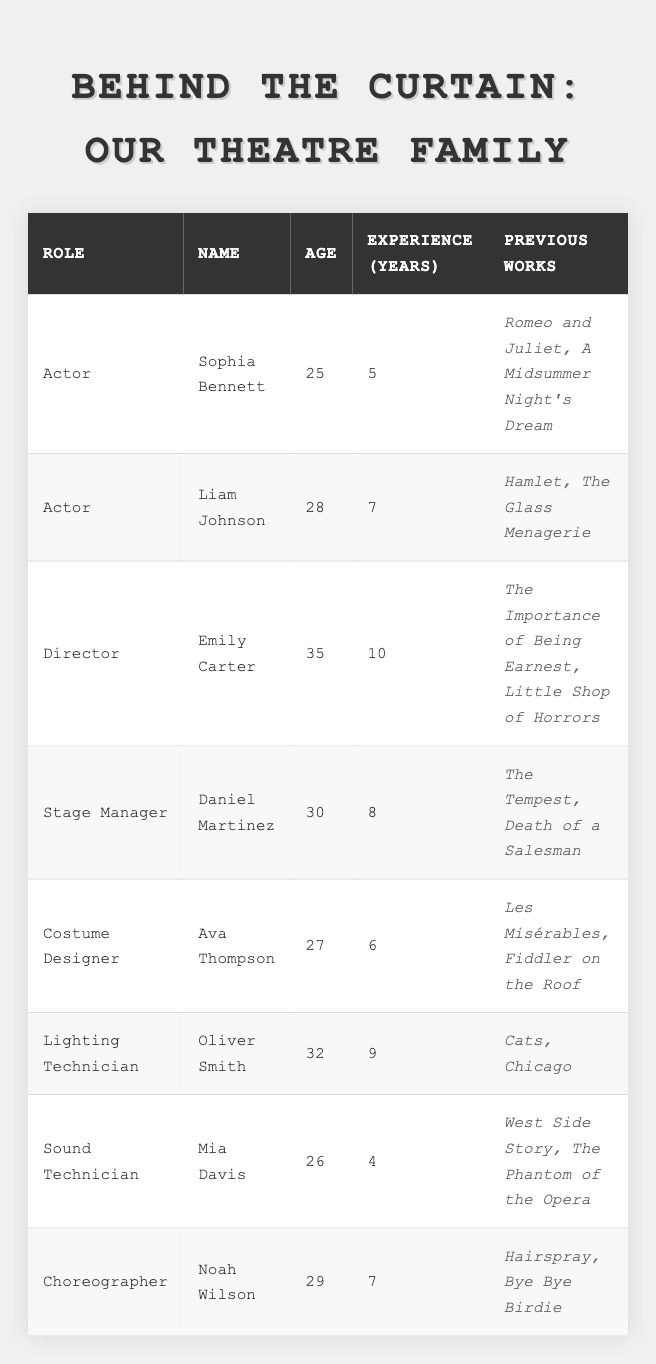What is the age of Sophia Bennett? Sophia Bennett is listed in the table, and her age is directly stated as 25.
Answer: 25 Who has the most experience? Emily Carter is a director with 10 years of experience, which is the highest compared to others in the table.
Answer: Emily Carter How many years of experience does Mia Davis have? Mia Davis is listed as a sound technician with 4 years of experience, which can be found in her entry.
Answer: 4 Are there any actors older than 30? The table shows that the only two actors are Sophia Bennett (25) and Liam Johnson (28), both of whom are younger than 30.
Answer: No What is the average age of the cast and crew? To find the average age, add all ages (25 + 28 + 35 + 30 + 27 + 32 + 26 + 29 = 232). Then divide by the number of entries (8), resulting in an average age of 29.
Answer: 29 How many total years of experience do the actors have? The two actors are Sophia Bennett (5 years) and Liam Johnson (7 years). Adding their experiences together gives 5 + 7 = 12 years.
Answer: 12 Which role has the youngest individual? Sophia Bennett is the youngest individual listed at 25 years old and she is an actor.
Answer: Actor Is Liam Johnson older than Daniel Martinez? Liam Johnson is 28 years old, while Daniel Martinez is 30 years old, making Daniel older than Liam.
Answer: No What role does Noah Wilson have and what is his experience? Noah Wilson is listed as a choreographer with 7 years of experience, found directly under his entry.
Answer: Choreographer, 7 years How many different roles are represented in the table? There are eight entries with distinct roles: Actor, Director, Stage Manager, Costume Designer, Lighting Technician, Sound Technician, and Choreographer. This makes a total of 7 different roles.
Answer: 7 